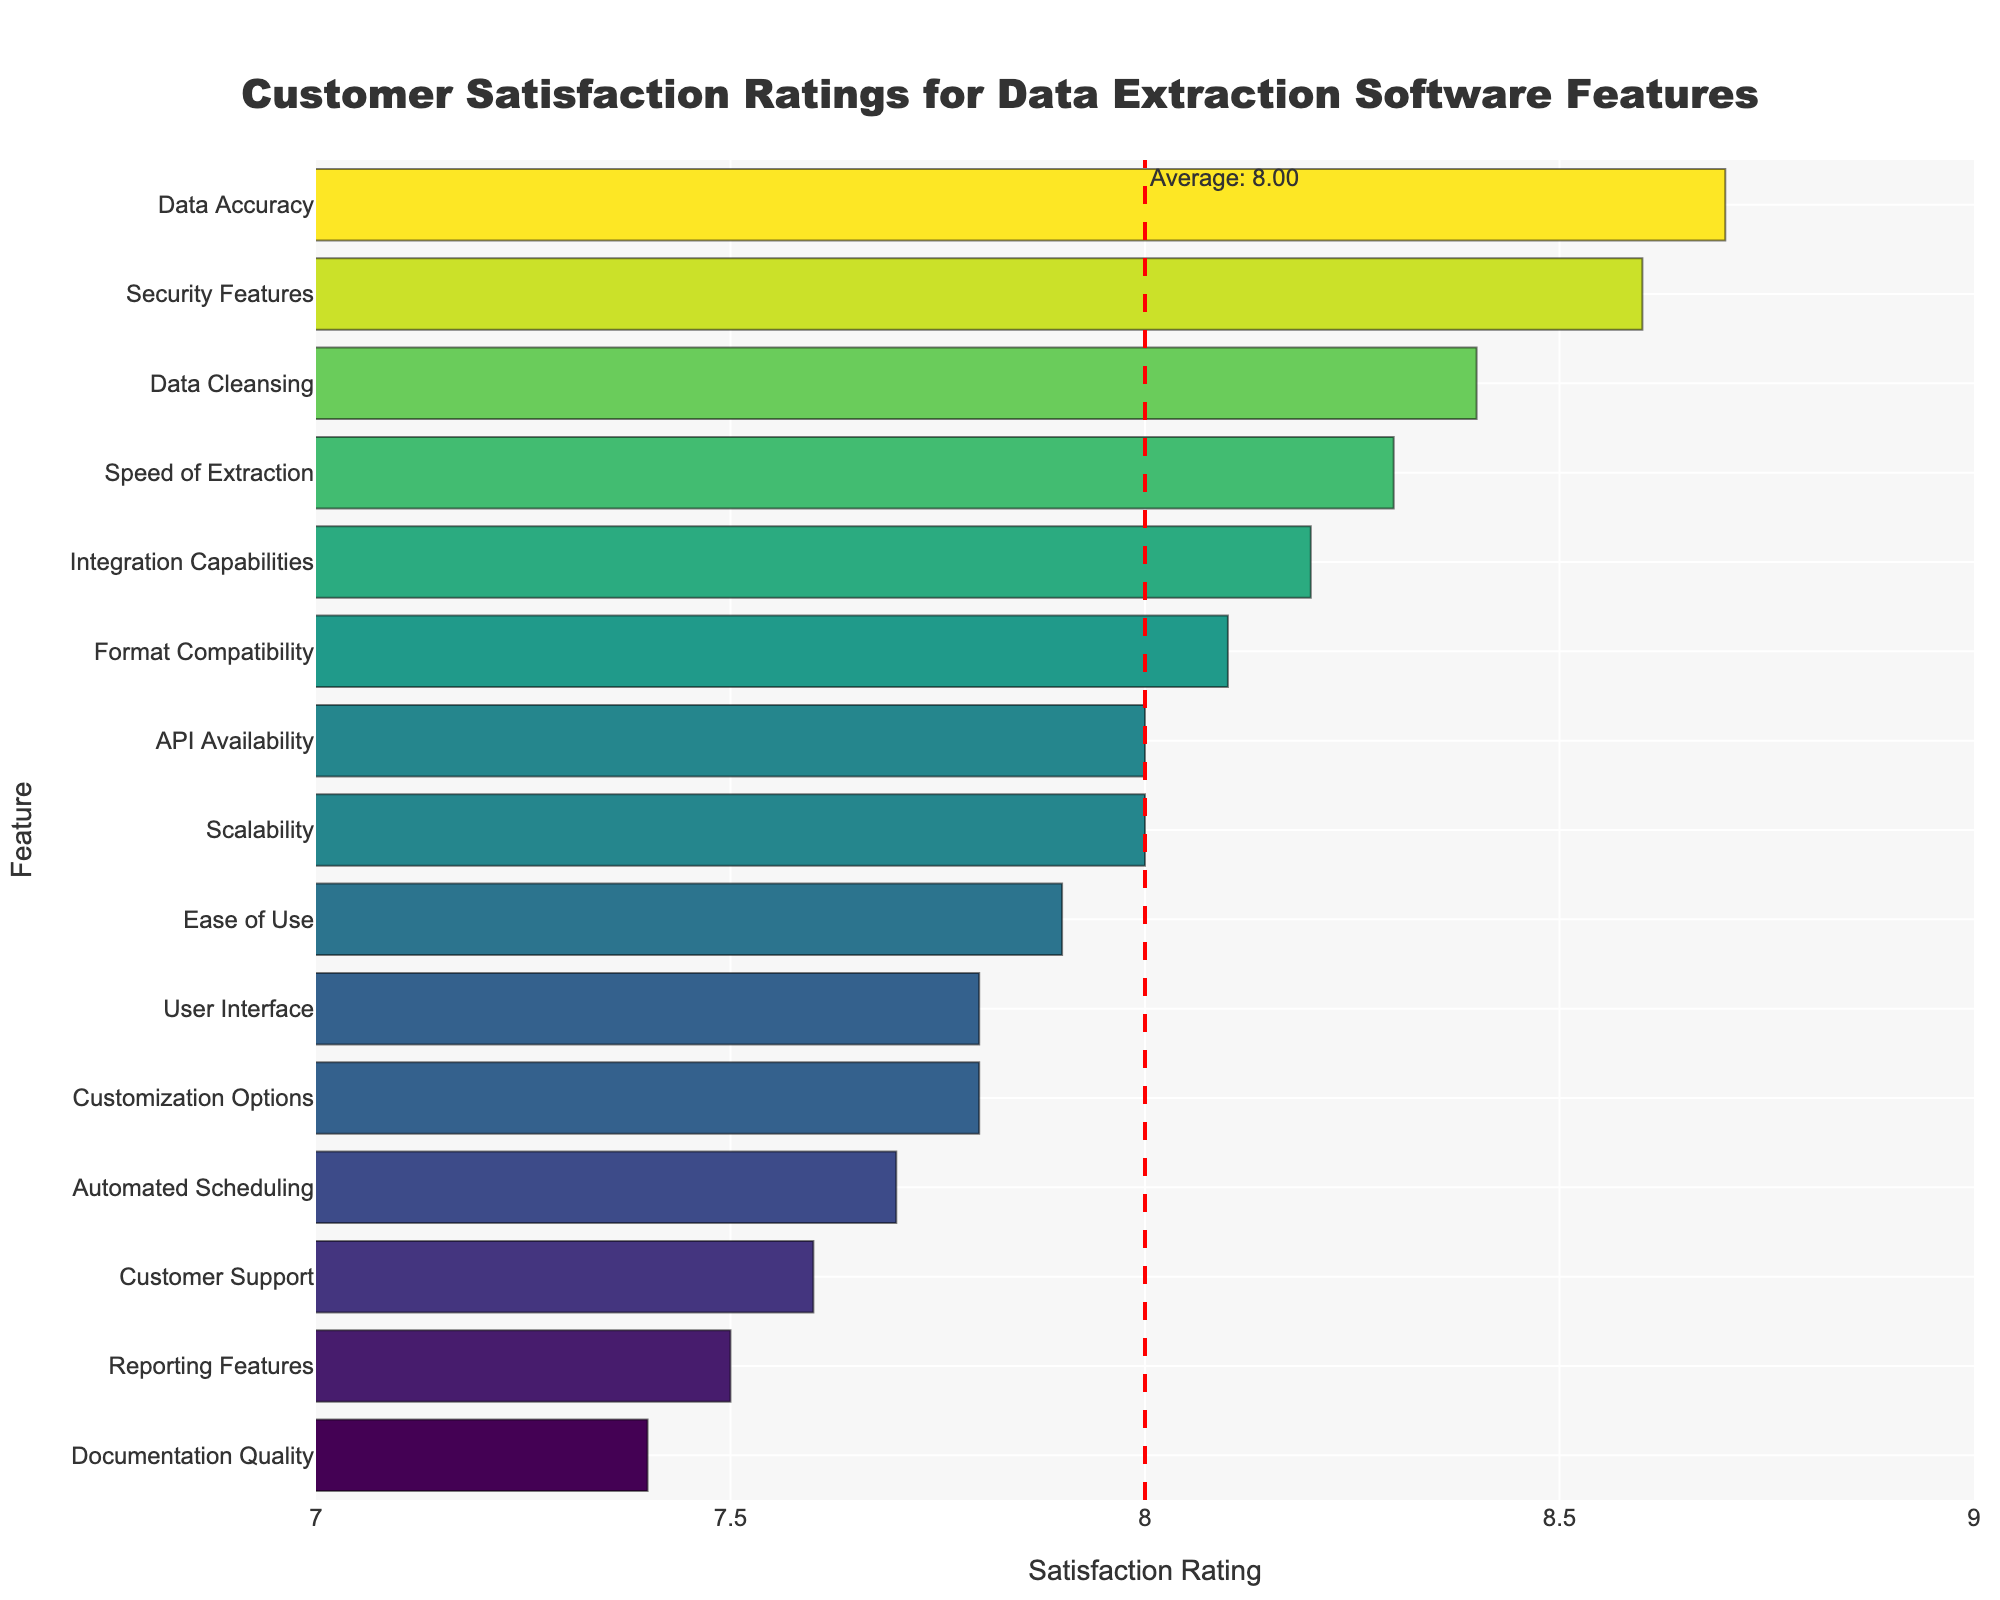Which feature has the highest customer satisfaction rating? By visually examining the bar which extends the furthest to the right, we can determine that "Data Accuracy" has the highest satisfaction rating.
Answer: Data Accuracy What is the average satisfaction rating of all the features? We can find the average line on the graph denoted by a red dashed line with the "Average: 8.02" annotation. Therefore, the average satisfaction rating is 8.02.
Answer: 8.02 Which feature has the lowest customer satisfaction rating? By looking for the shortest bar in the chart, we identify that "Documentation Quality" has the lowest satisfaction rating.
Answer: Documentation Quality How much more satisfied are customers with "Data Accuracy" than with "Documentation Quality"? The rating for "Data Accuracy" is 8.7, and for "Documentation Quality" is 7.4. Therefore, the difference is 8.7 - 7.4 = 1.3.
Answer: 1.3 Which features have a satisfaction rating greater than or equal to the average rating? The average rating is 8.02. Features with ratings greater than or equal to 8.02 are "Data Accuracy", "Speed of Extraction", "Format Compatibility", "Integration Capabilities", "Scalability", "Data Cleansing", "Security Features", and "API Availability".
Answer: Data Accuracy, Speed of Extraction, Format Compatibility, Integration Capabilities, Scalability, Data Cleansing, Security Features, API Availability How does the satisfaction rating of "Ease of Use" compare to "Customer Support"? "Ease of Use" has a rating of 7.9, while "Customer Support" has a rating of 7.6. Hence, customers are more satisfied with "Ease of Use" than "Customer Support".
Answer: Ease of Use is higher What is the combined satisfaction rating of "API Availability" and "Security Features"? The satisfaction rating for "API Availability" is 8.0 and for "Security Features" is 8.6. The combined rating is 8.0 + 8.6 = 16.6.
Answer: 16.6 Which feature with a rating above 8.0 has the least customer satisfaction? Among features with a rating above 8.0, "Format Compatibility" has the lowest rating of 8.1.
Answer: Format Compatibility 